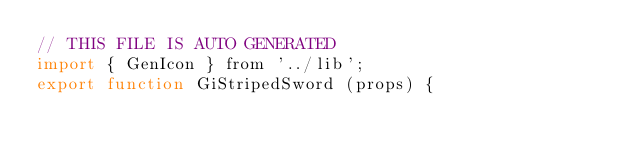Convert code to text. <code><loc_0><loc_0><loc_500><loc_500><_JavaScript_>// THIS FILE IS AUTO GENERATED
import { GenIcon } from '../lib';
export function GiStripedSword (props) {</code> 